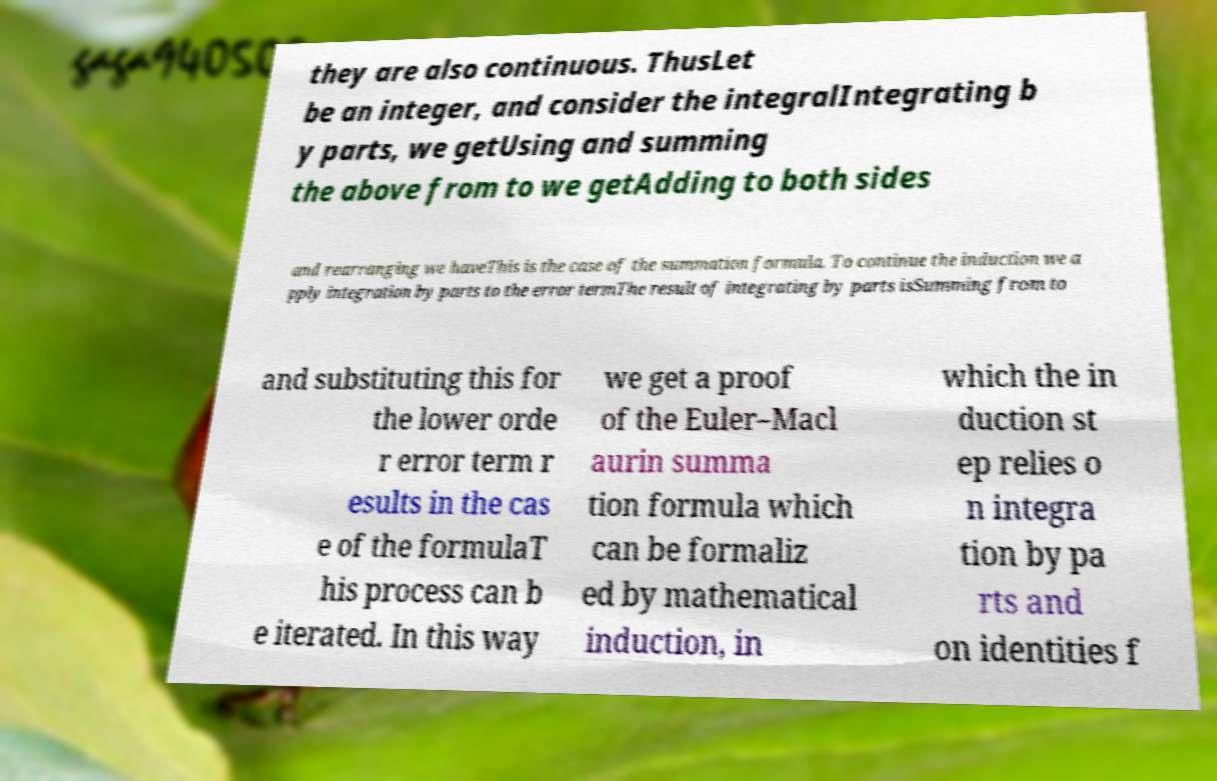What messages or text are displayed in this image? I need them in a readable, typed format. they are also continuous. ThusLet be an integer, and consider the integralIntegrating b y parts, we getUsing and summing the above from to we getAdding to both sides and rearranging we haveThis is the case of the summation formula. To continue the induction we a pply integration by parts to the error termThe result of integrating by parts isSumming from to and substituting this for the lower orde r error term r esults in the cas e of the formulaT his process can b e iterated. In this way we get a proof of the Euler–Macl aurin summa tion formula which can be formaliz ed by mathematical induction, in which the in duction st ep relies o n integra tion by pa rts and on identities f 